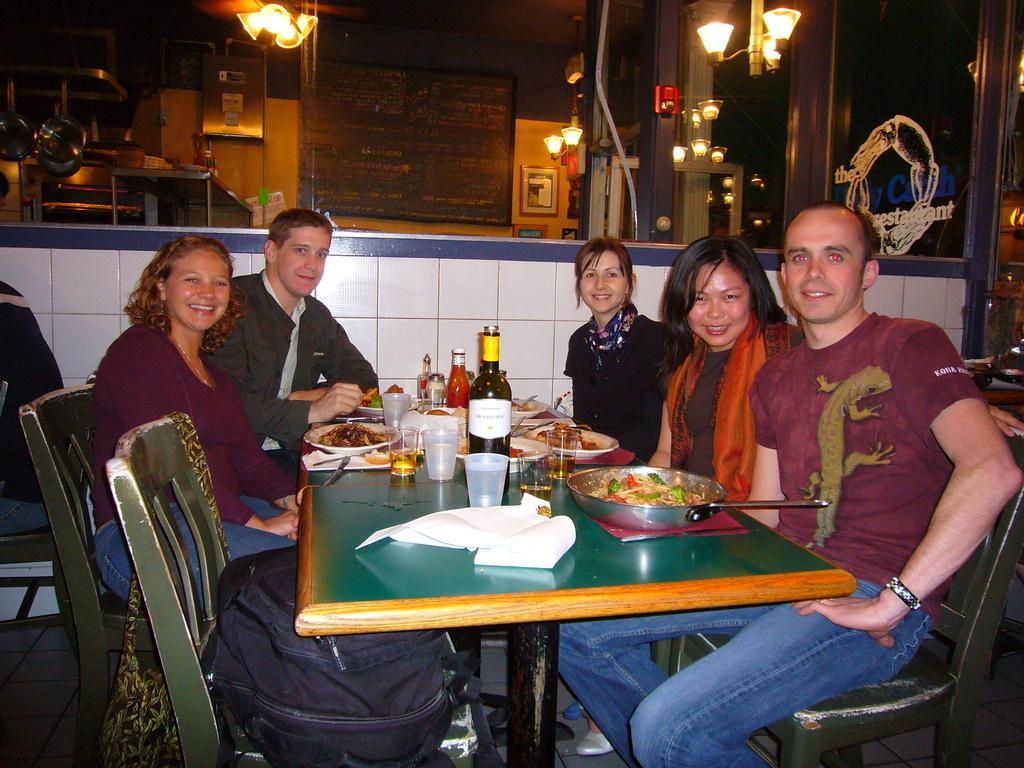Please provide a concise description of this image. Five persons are sitting on the chairs. On the table we can see bottles,glasses,spoons,food,papers. On the background we can see lights,board,wall. 